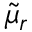Convert formula to latex. <formula><loc_0><loc_0><loc_500><loc_500>\widetilde { \mu } _ { r }</formula> 